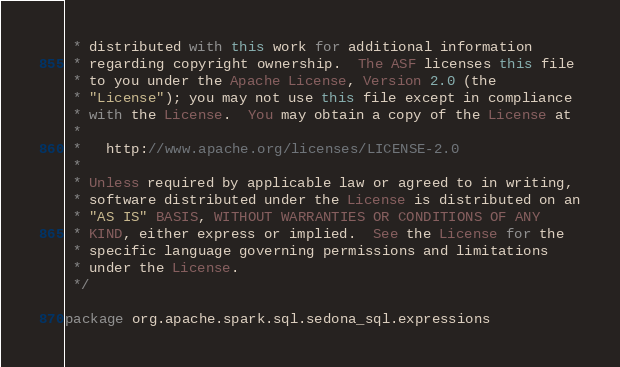<code> <loc_0><loc_0><loc_500><loc_500><_Scala_> * distributed with this work for additional information
 * regarding copyright ownership.  The ASF licenses this file
 * to you under the Apache License, Version 2.0 (the
 * "License"); you may not use this file except in compliance
 * with the License.  You may obtain a copy of the License at
 *
 *   http://www.apache.org/licenses/LICENSE-2.0
 *
 * Unless required by applicable law or agreed to in writing,
 * software distributed under the License is distributed on an
 * "AS IS" BASIS, WITHOUT WARRANTIES OR CONDITIONS OF ANY
 * KIND, either express or implied.  See the License for the
 * specific language governing permissions and limitations
 * under the License.
 */

package org.apache.spark.sql.sedona_sql.expressions
</code> 